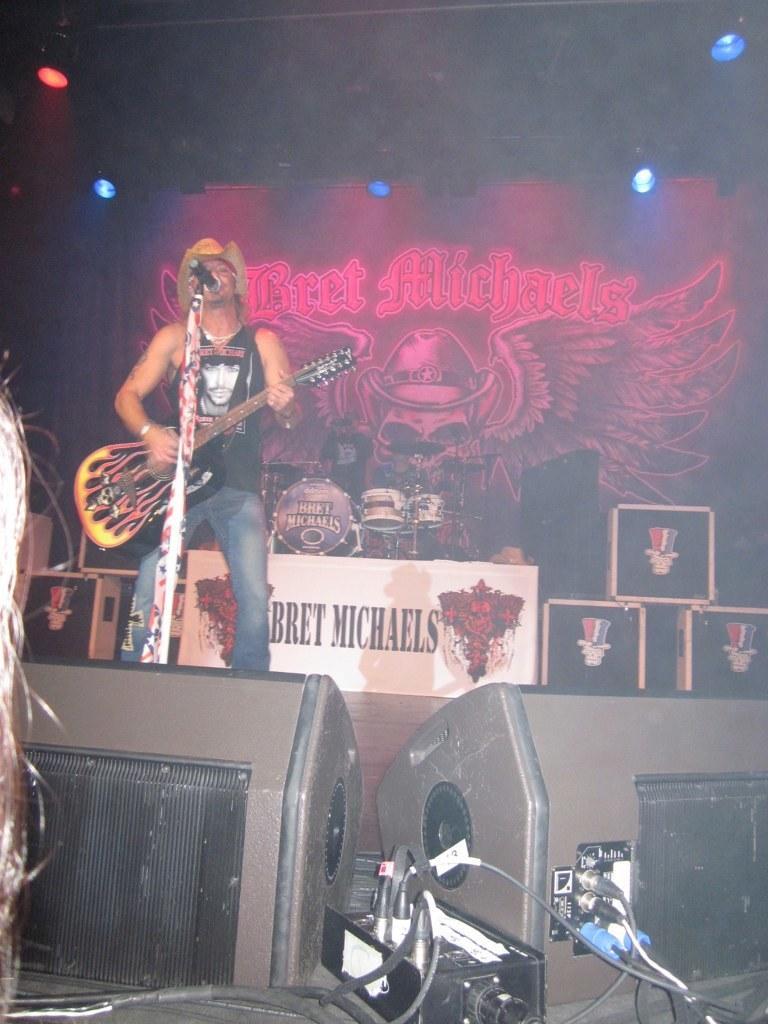How would you summarize this image in a sentence or two? There is a person standing on a stage on the left side. He is holding a guitar in his hand. He is playing a guitar and singing on a microphone. 